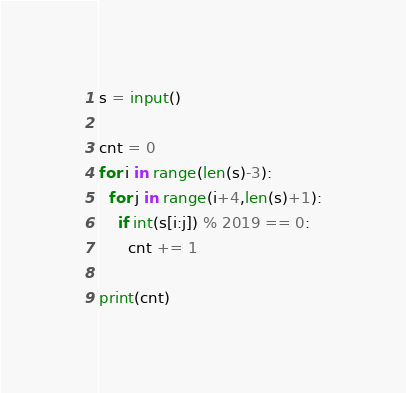<code> <loc_0><loc_0><loc_500><loc_500><_Python_>s = input()

cnt = 0
for i in range(len(s)-3):
  for j in range(i+4,len(s)+1):
    if int(s[i:j]) % 2019 == 0:
      cnt += 1

print(cnt)</code> 